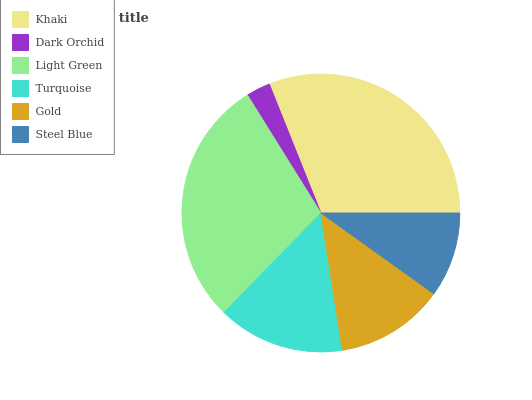Is Dark Orchid the minimum?
Answer yes or no. Yes. Is Khaki the maximum?
Answer yes or no. Yes. Is Light Green the minimum?
Answer yes or no. No. Is Light Green the maximum?
Answer yes or no. No. Is Light Green greater than Dark Orchid?
Answer yes or no. Yes. Is Dark Orchid less than Light Green?
Answer yes or no. Yes. Is Dark Orchid greater than Light Green?
Answer yes or no. No. Is Light Green less than Dark Orchid?
Answer yes or no. No. Is Turquoise the high median?
Answer yes or no. Yes. Is Gold the low median?
Answer yes or no. Yes. Is Light Green the high median?
Answer yes or no. No. Is Dark Orchid the low median?
Answer yes or no. No. 